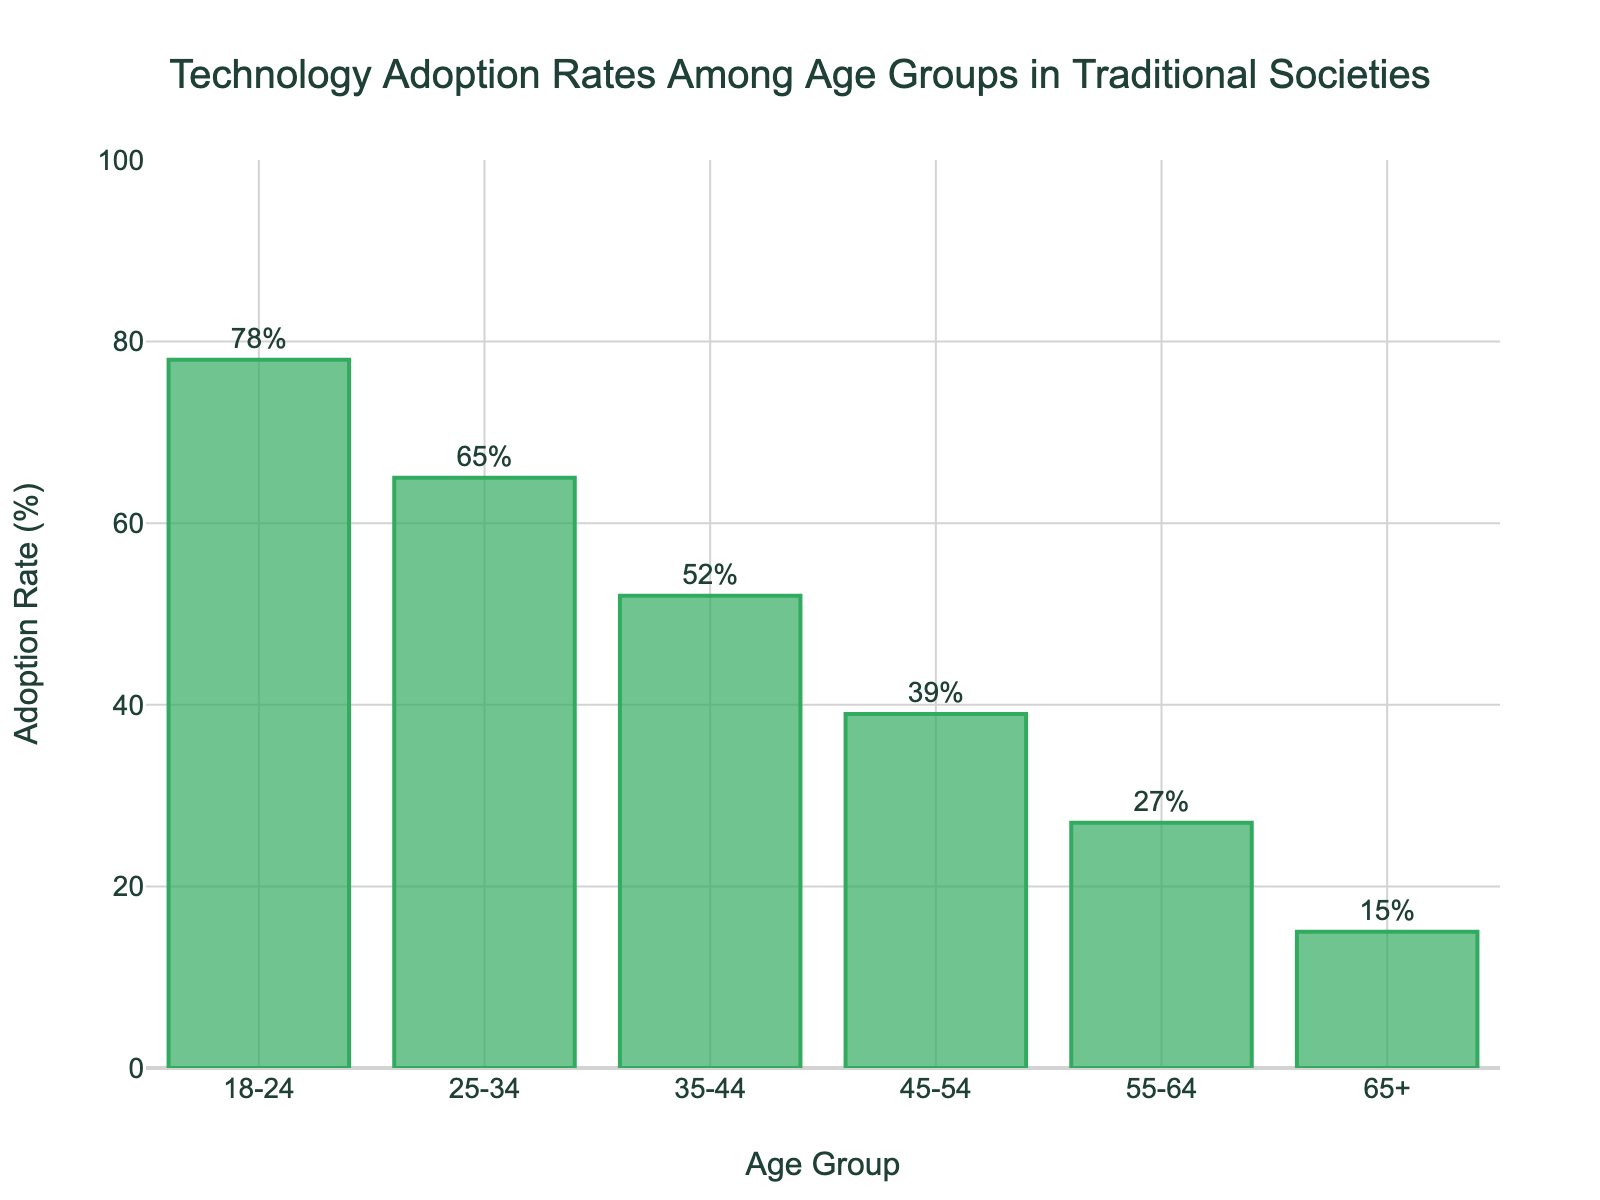What is the technology adoption rate of the 18-24 age group? Look at the height of the bar for the 18-24 age group. The figure shows that the percentage labeled on this bar is 78%.
Answer: 78% What is the difference in adoption rates between the 35-44 and 55-64 age groups? Find the adoption rates for the 35-44 (52%) and 55-64 (27%) age groups, then calculate the difference: 52% - 27% = 25%.
Answer: 25% Which age group has the lowest technology adoption rate? Compare the height of all bars; the shortest bar represents the 65+ age group. The adoption rate is 15%.
Answer: 65+ How much higher is the adoption rate of the 18-24 age group compared to the 25-34 age group? Find the adoption rates for the 18-24 (78%) and 25-34 (65%) age groups, then calculate the difference: 78% - 65% = 13%.
Answer: 13% What is the combined adoption rate of the 18-24 and 65+ age groups? Add the adoption rates of the 18-24 (78%) and 65+ (15%) age groups: 78% + 15% = 93%.
Answer: 93% What is the average adoption rate of all age groups shown? Sum the adoption rates of all age groups (78% + 65% + 52% + 39% + 27% + 15%) and divide by the number of age groups (6). The total is 276%, so the average is 276% / 6 = 46%.
Answer: 46% Which two consecutive age groups have the largest drop in adoption rates? Calculate the differences in adoption rates for consecutive age groups: 78%-65% (13%), 65%-52% (13%), 52%-39% (13%), 39%-27% (12%), 27%-15% (12%). The largest drops are 78%-65%, 65%-52%, and 52%-39%, all equal to 13%.
Answer: 18-24 to 25-34, 25-34 to 35-44, 35-44 to 45-54 How many age groups have an adoption rate above 50%? Count the bars with an adoption rate higher than 50%. The bars for age groups 18-24, 25-34, and 35-44 all exceed 50%. Therefore, there are 3 such groups.
Answer: 3 By how much does the adoption rate decrease from the 25-34 to the 55-64 age group? Subtract the adoption rate of the 55-64 (27%) group from that of the 25-34 (65%) group: 65% - 27% = 38%.
Answer: 38% Which age groups are above and below the average adoption rate? Calculate the average adoption rate (46%). Age groups 18-24 (78%), 25-34 (65%), and 35-44 (52%) are above the average, while 45-54 (39%), 55-64 (27%), and 65+ (15%) are below.
Answer: Above average: 18-24, 25-34, 35-44. Below average: 45-54, 55-64, 65+ 